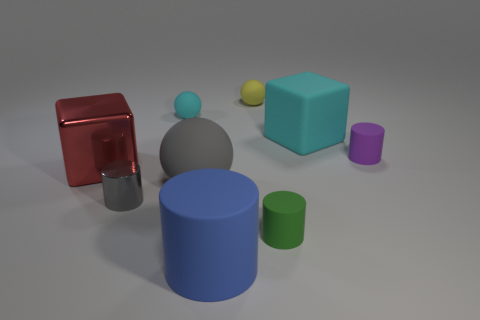There is a block that is to the left of the large thing that is to the right of the big blue matte cylinder; what size is it?
Ensure brevity in your answer.  Large. Are there an equal number of gray balls to the left of the big gray matte thing and brown cylinders?
Your response must be concise. Yes. What number of other objects are the same color as the metal block?
Keep it short and to the point. 0. Are there fewer cyan blocks left of the large blue cylinder than big blue cylinders?
Give a very brief answer. Yes. Are there any gray metal cylinders of the same size as the purple thing?
Your answer should be compact. Yes. There is a rubber block; does it have the same color as the big block to the left of the tiny yellow thing?
Offer a terse response. No. What number of objects are behind the cyan object that is on the left side of the green matte thing?
Provide a succinct answer. 1. What color is the big block that is to the left of the tiny matte cylinder that is in front of the red thing?
Ensure brevity in your answer.  Red. The ball that is behind the purple thing and in front of the yellow ball is made of what material?
Make the answer very short. Rubber. Is there a tiny cyan object of the same shape as the big gray thing?
Ensure brevity in your answer.  Yes. 